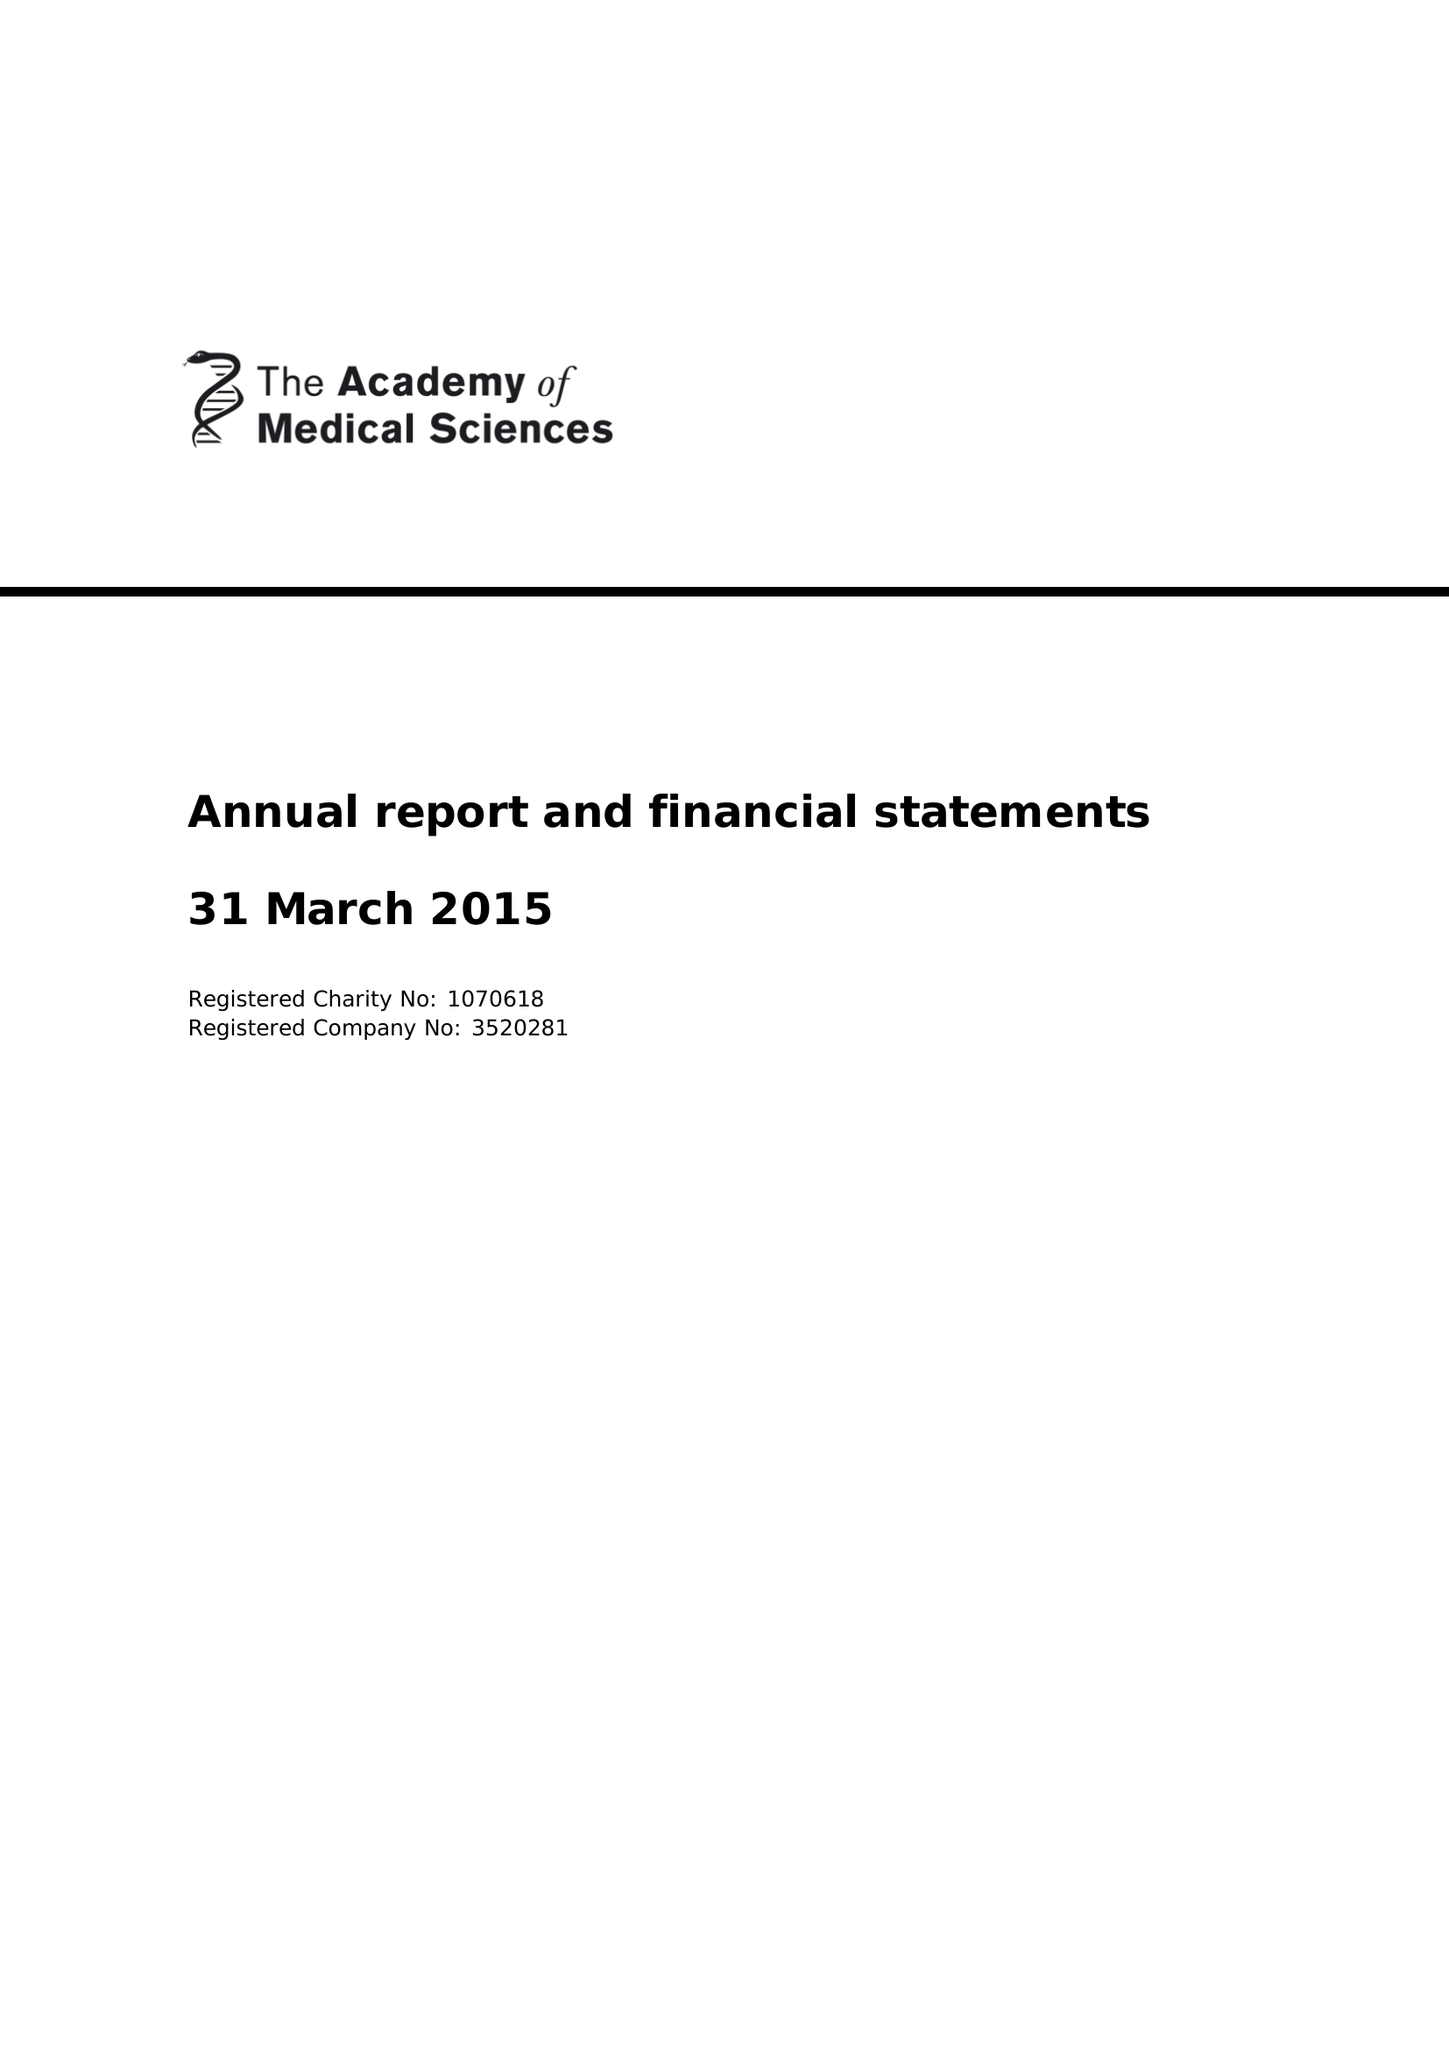What is the value for the address__street_line?
Answer the question using a single word or phrase. 41 PORTLAND PLACE 